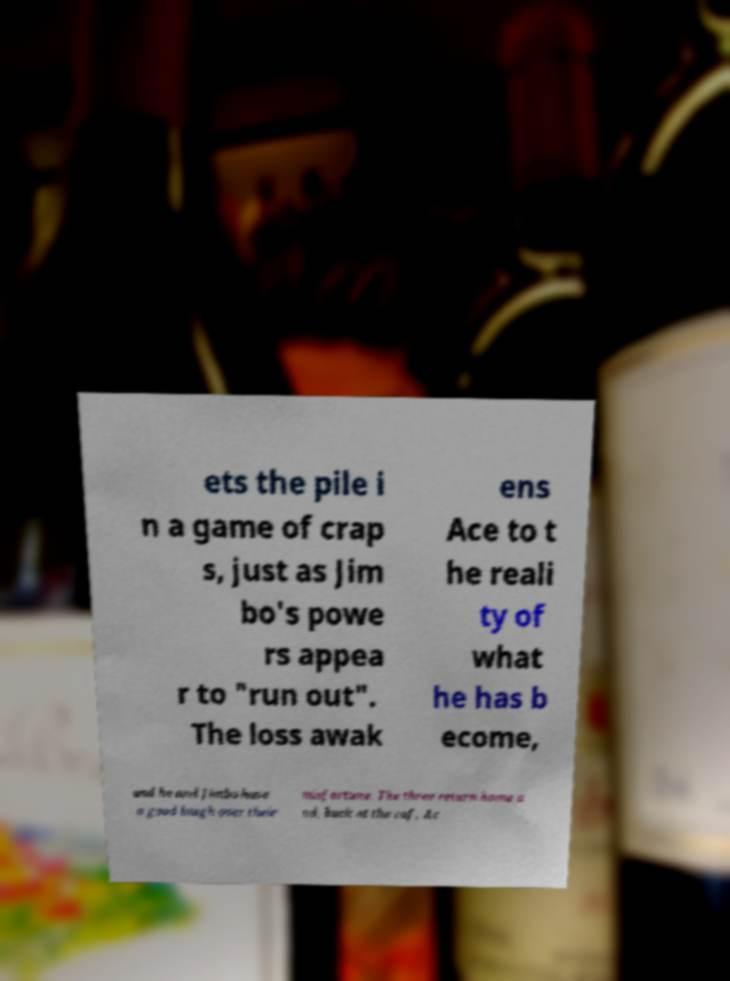There's text embedded in this image that I need extracted. Can you transcribe it verbatim? ets the pile i n a game of crap s, just as Jim bo's powe rs appea r to "run out". The loss awak ens Ace to t he reali ty of what he has b ecome, and he and Jimbo have a good laugh over their misfortune. The three return home a nd, back at the caf, Ac 